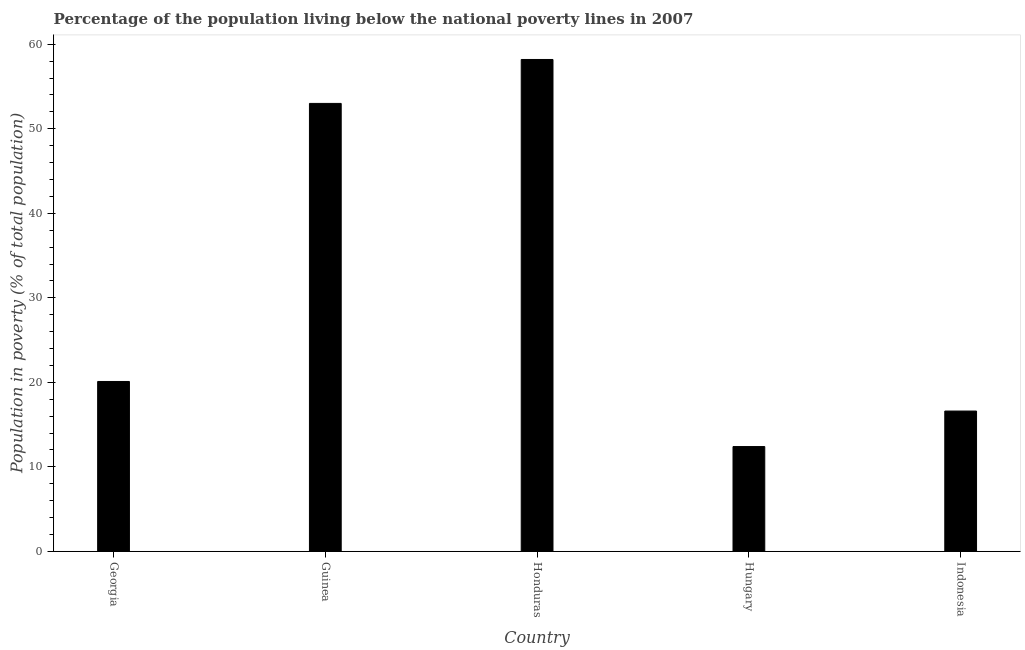Does the graph contain any zero values?
Give a very brief answer. No. Does the graph contain grids?
Provide a succinct answer. No. What is the title of the graph?
Give a very brief answer. Percentage of the population living below the national poverty lines in 2007. What is the label or title of the X-axis?
Give a very brief answer. Country. What is the label or title of the Y-axis?
Your response must be concise. Population in poverty (% of total population). What is the percentage of population living below poverty line in Honduras?
Offer a terse response. 58.2. Across all countries, what is the maximum percentage of population living below poverty line?
Offer a terse response. 58.2. In which country was the percentage of population living below poverty line maximum?
Keep it short and to the point. Honduras. In which country was the percentage of population living below poverty line minimum?
Provide a succinct answer. Hungary. What is the sum of the percentage of population living below poverty line?
Offer a very short reply. 160.3. What is the difference between the percentage of population living below poverty line in Honduras and Indonesia?
Keep it short and to the point. 41.6. What is the average percentage of population living below poverty line per country?
Your answer should be very brief. 32.06. What is the median percentage of population living below poverty line?
Keep it short and to the point. 20.1. What is the ratio of the percentage of population living below poverty line in Georgia to that in Hungary?
Your response must be concise. 1.62. Is the percentage of population living below poverty line in Guinea less than that in Indonesia?
Offer a very short reply. No. What is the difference between the highest and the second highest percentage of population living below poverty line?
Keep it short and to the point. 5.2. Is the sum of the percentage of population living below poverty line in Honduras and Hungary greater than the maximum percentage of population living below poverty line across all countries?
Your answer should be very brief. Yes. What is the difference between the highest and the lowest percentage of population living below poverty line?
Your response must be concise. 45.8. How many bars are there?
Your answer should be very brief. 5. Are all the bars in the graph horizontal?
Keep it short and to the point. No. What is the Population in poverty (% of total population) in Georgia?
Offer a very short reply. 20.1. What is the Population in poverty (% of total population) in Honduras?
Give a very brief answer. 58.2. What is the Population in poverty (% of total population) in Indonesia?
Give a very brief answer. 16.6. What is the difference between the Population in poverty (% of total population) in Georgia and Guinea?
Offer a terse response. -32.9. What is the difference between the Population in poverty (% of total population) in Georgia and Honduras?
Your answer should be compact. -38.1. What is the difference between the Population in poverty (% of total population) in Georgia and Hungary?
Ensure brevity in your answer.  7.7. What is the difference between the Population in poverty (% of total population) in Guinea and Hungary?
Your answer should be compact. 40.6. What is the difference between the Population in poverty (% of total population) in Guinea and Indonesia?
Provide a short and direct response. 36.4. What is the difference between the Population in poverty (% of total population) in Honduras and Hungary?
Your answer should be compact. 45.8. What is the difference between the Population in poverty (% of total population) in Honduras and Indonesia?
Your answer should be compact. 41.6. What is the difference between the Population in poverty (% of total population) in Hungary and Indonesia?
Make the answer very short. -4.2. What is the ratio of the Population in poverty (% of total population) in Georgia to that in Guinea?
Offer a terse response. 0.38. What is the ratio of the Population in poverty (% of total population) in Georgia to that in Honduras?
Provide a short and direct response. 0.34. What is the ratio of the Population in poverty (% of total population) in Georgia to that in Hungary?
Your answer should be compact. 1.62. What is the ratio of the Population in poverty (% of total population) in Georgia to that in Indonesia?
Provide a succinct answer. 1.21. What is the ratio of the Population in poverty (% of total population) in Guinea to that in Honduras?
Give a very brief answer. 0.91. What is the ratio of the Population in poverty (% of total population) in Guinea to that in Hungary?
Give a very brief answer. 4.27. What is the ratio of the Population in poverty (% of total population) in Guinea to that in Indonesia?
Ensure brevity in your answer.  3.19. What is the ratio of the Population in poverty (% of total population) in Honduras to that in Hungary?
Your response must be concise. 4.69. What is the ratio of the Population in poverty (% of total population) in Honduras to that in Indonesia?
Ensure brevity in your answer.  3.51. What is the ratio of the Population in poverty (% of total population) in Hungary to that in Indonesia?
Keep it short and to the point. 0.75. 